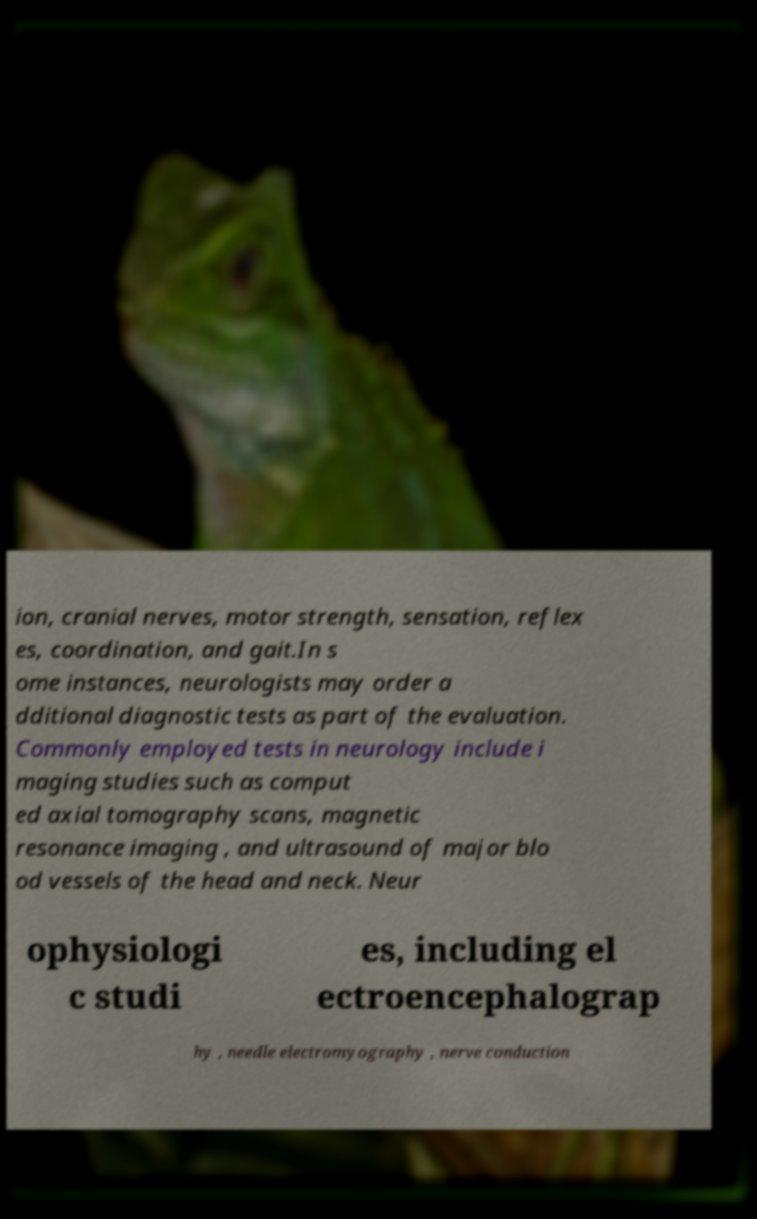Could you assist in decoding the text presented in this image and type it out clearly? ion, cranial nerves, motor strength, sensation, reflex es, coordination, and gait.In s ome instances, neurologists may order a dditional diagnostic tests as part of the evaluation. Commonly employed tests in neurology include i maging studies such as comput ed axial tomography scans, magnetic resonance imaging , and ultrasound of major blo od vessels of the head and neck. Neur ophysiologi c studi es, including el ectroencephalograp hy , needle electromyography , nerve conduction 